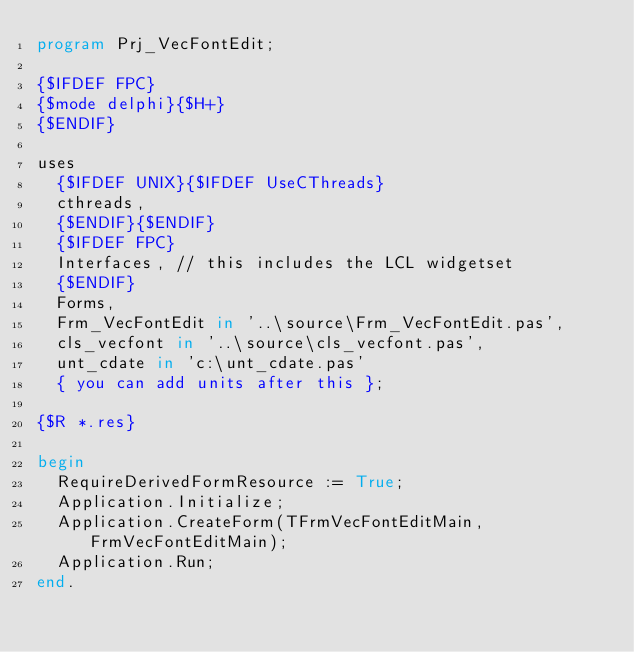<code> <loc_0><loc_0><loc_500><loc_500><_Pascal_>program Prj_VecFontEdit;

{$IFDEF FPC}
{$mode delphi}{$H+}
{$ENDIF}

uses
  {$IFDEF UNIX}{$IFDEF UseCThreads}
  cthreads,
  {$ENDIF}{$ENDIF}
  {$IFDEF FPC}
  Interfaces, // this includes the LCL widgetset
  {$ENDIF}
  Forms,
  Frm_VecFontEdit in '..\source\Frm_VecFontEdit.pas',
  cls_vecfont in '..\source\cls_vecfont.pas',
  unt_cdate in 'c:\unt_cdate.pas'
  { you can add units after this };

{$R *.res}

begin
  RequireDerivedFormResource := True;
  Application.Initialize;
  Application.CreateForm(TFrmVecFontEditMain, FrmVecFontEditMain);
  Application.Run;
end.

</code> 